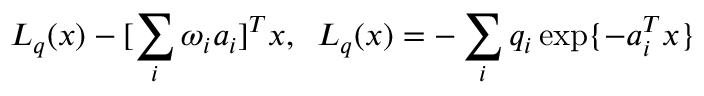Convert formula to latex. <formula><loc_0><loc_0><loc_500><loc_500>L _ { q } ( x ) - [ \sum _ { i } \omega _ { i } a _ { i } ] ^ { T } x , \, L _ { q } ( x ) = - \sum _ { i } q _ { i } \exp \{ - a _ { i } ^ { T } x \}</formula> 